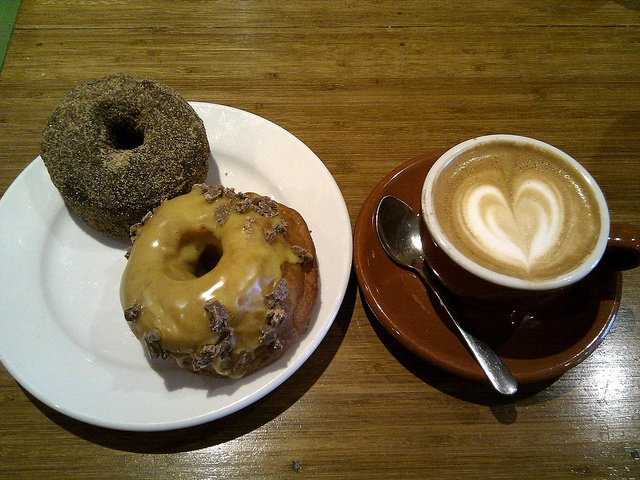Describe the objects in this image and their specific colors. I can see dining table in darkgreen, olive, maroon, and black tones, cup in darkgreen, black, olive, and tan tones, donut in darkgreen, olive, and maroon tones, donut in darkgreen, black, olive, and gray tones, and spoon in darkgreen, black, gray, and white tones in this image. 